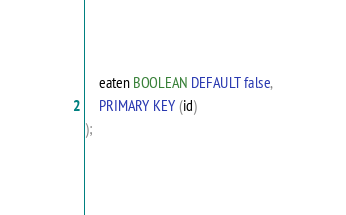Convert code to text. <code><loc_0><loc_0><loc_500><loc_500><_SQL_>	eaten BOOLEAN DEFAULT false,
	PRIMARY KEY (id)
);
</code> 